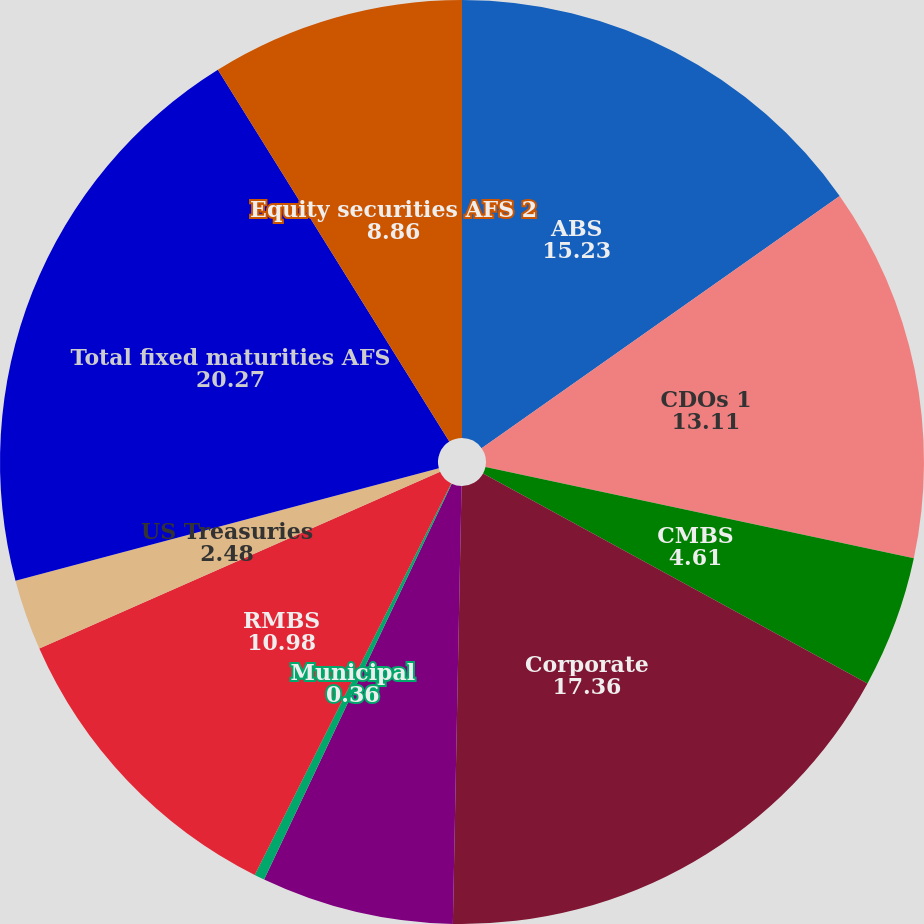Convert chart. <chart><loc_0><loc_0><loc_500><loc_500><pie_chart><fcel>ABS<fcel>CDOs 1<fcel>CMBS<fcel>Corporate<fcel>Foreign govt/govt agencies<fcel>Municipal<fcel>RMBS<fcel>US Treasuries<fcel>Total fixed maturities AFS<fcel>Equity securities AFS 2<nl><fcel>15.23%<fcel>13.11%<fcel>4.61%<fcel>17.36%<fcel>6.73%<fcel>0.36%<fcel>10.98%<fcel>2.48%<fcel>20.27%<fcel>8.86%<nl></chart> 